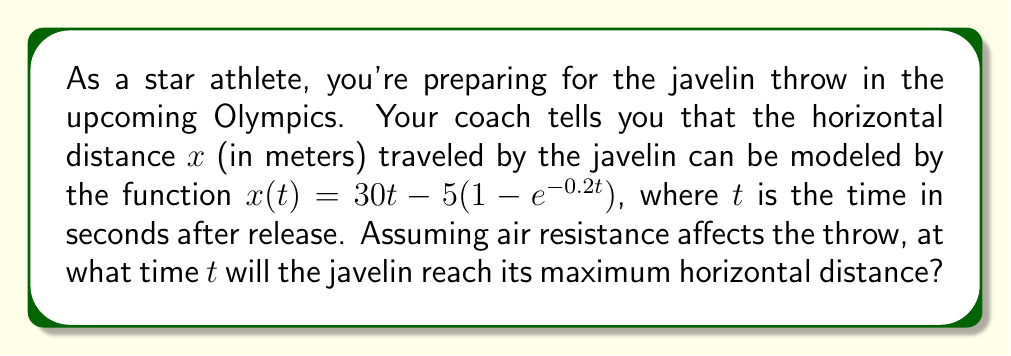Show me your answer to this math problem. To find the time when the javelin reaches its maximum horizontal distance, we need to find the time when the velocity of the javelin in the horizontal direction becomes zero. This occurs when the derivative of the distance function equals zero.

1) First, let's find the derivative of $x(t)$ with respect to $t$:

   $$\frac{dx}{dt} = 30 - 5(-0.2e^{-0.2t}) = 30 + e^{-0.2t}$$

2) Now, we set this equal to zero and solve for $t$:

   $$30 + e^{-0.2t} = 0$$
   $$e^{-0.2t} = -30$$

3) Taking the natural logarithm of both sides:

   $$-0.2t = \ln(-30)$$

4) However, we can't take the natural logarithm of a negative number in the real number system. This means that the equation has no real solution.

5) This implies that the horizontal velocity never actually reaches zero due to the effects of air resistance. The javelin will continue to move forward, albeit at an ever-decreasing rate.

6) In practical terms, this means that the javelin will reach its maximum distance when it hits the ground, not while it's in the air.

7) To find when it hits the ground, we would need additional information about the vertical motion of the javelin, which is not provided in this problem.

Therefore, theoretically, there is no specific time when the javelin reaches its maximum horizontal distance in the air. The distance will approach a limit as time increases indefinitely.
Answer: There is no specific time when the javelin reaches its maximum horizontal distance in the air due to the continuous effect of air resistance. The javelin's horizontal distance approaches a limit as time increases indefinitely. 